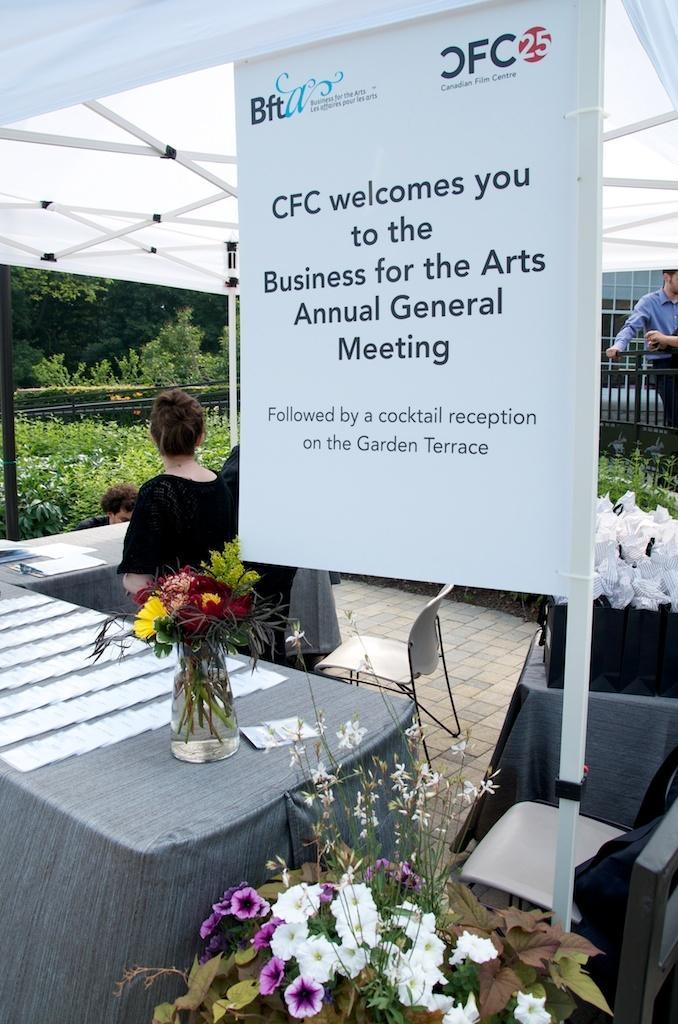How would you summarize this image in a sentence or two? Under this tent there is a white banner. Far there are plants and trees. In-front of this tables persons are standing. We can able to see chairs. On this tables there are papers and bags. Beside this table there is a bouquet. 